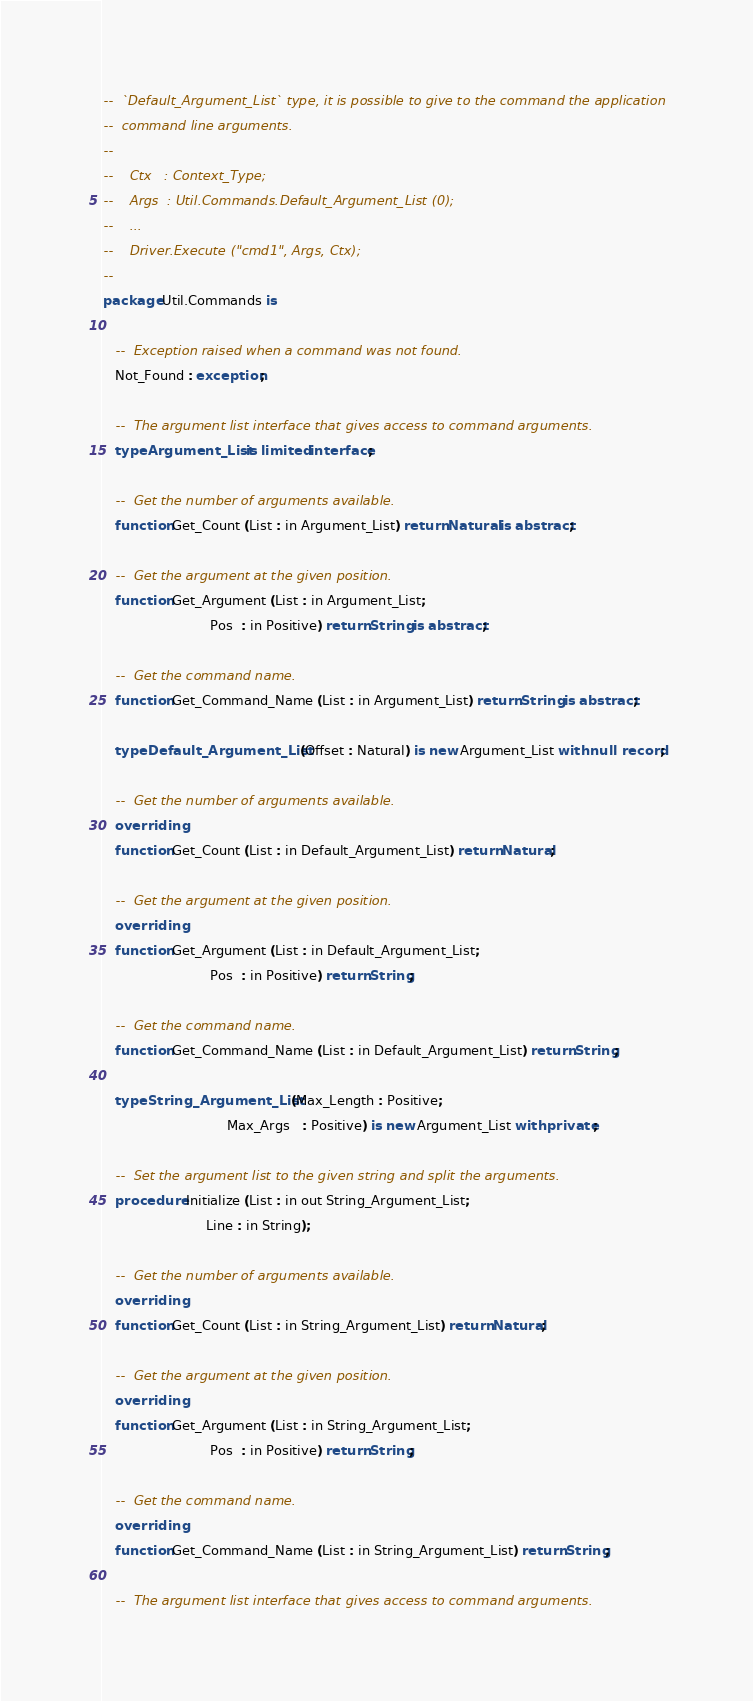<code> <loc_0><loc_0><loc_500><loc_500><_Ada_>--  `Default_Argument_List` type, it is possible to give to the command the application
--  command line arguments.
--
--    Ctx   : Context_Type;
--    Args  : Util.Commands.Default_Argument_List (0);
--    ...
--    Driver.Execute ("cmd1", Args, Ctx);
--
package Util.Commands is

   --  Exception raised when a command was not found.
   Not_Found : exception;

   --  The argument list interface that gives access to command arguments.
   type Argument_List is limited interface;

   --  Get the number of arguments available.
   function Get_Count (List : in Argument_List) return Natural is abstract;

   --  Get the argument at the given position.
   function Get_Argument (List : in Argument_List;
                          Pos  : in Positive) return String is abstract;

   --  Get the command name.
   function Get_Command_Name (List : in Argument_List) return String is abstract;

   type Default_Argument_List (Offset : Natural) is new Argument_List with null record;

   --  Get the number of arguments available.
   overriding
   function Get_Count (List : in Default_Argument_List) return Natural;

   --  Get the argument at the given position.
   overriding
   function Get_Argument (List : in Default_Argument_List;
                          Pos  : in Positive) return String;

   --  Get the command name.
   function Get_Command_Name (List : in Default_Argument_List) return String;

   type String_Argument_List (Max_Length : Positive;
                              Max_Args   : Positive) is new Argument_List with private;

   --  Set the argument list to the given string and split the arguments.
   procedure Initialize (List : in out String_Argument_List;
                         Line : in String);

   --  Get the number of arguments available.
   overriding
   function Get_Count (List : in String_Argument_List) return Natural;

   --  Get the argument at the given position.
   overriding
   function Get_Argument (List : in String_Argument_List;
                          Pos  : in Positive) return String;

   --  Get the command name.
   overriding
   function Get_Command_Name (List : in String_Argument_List) return String;

   --  The argument list interface that gives access to command arguments.</code> 